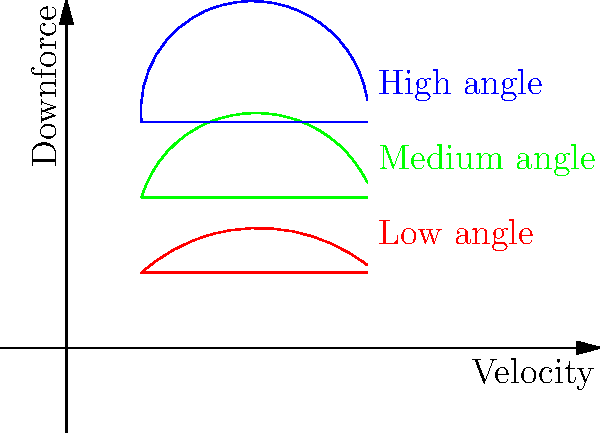Based on the graph showing three different wing configurations, which configuration would likely produce the highest downforce at high speeds, and why is this crucial for Formula 1 cars? To answer this question, let's analyze the graph step-by-step:

1. The graph shows three wing configurations: low angle (red), medium angle (green), and high angle (blue).

2. In aerodynamics, the angle of attack (AoA) of a wing affects its ability to generate downforce. A higher AoA generally produces more downforce, up to a certain point.

3. The blue line represents the high angle configuration, which has the steepest curve on the graph. This indicates that it generates the most downforce as velocity increases.

4. In Formula 1, downforce is crucial because:
   a) It increases the car's grip on the track, allowing for higher cornering speeds.
   b) It improves stability, especially in high-speed corners.
   c) It helps with braking performance by increasing the normal force on the tires.

5. However, there's a trade-off: higher downforce also creates more drag, which can reduce top speed on straights. F1 teams must balance downforce and drag for optimal performance.

6. The high angle (blue) configuration would likely produce the highest downforce at high speeds, which is particularly beneficial for tracks with many high-speed corners.

7. F1 drivers need to understand these aerodynamic principles to provide feedback to their teams and adapt their driving style to different wing configurations.
Answer: High angle (blue) configuration; maximizes grip and stability in high-speed corners. 